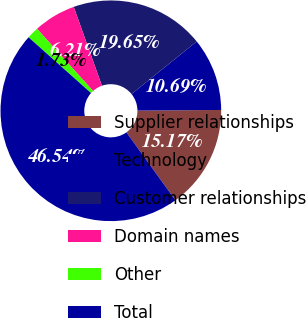<chart> <loc_0><loc_0><loc_500><loc_500><pie_chart><fcel>Supplier relationships<fcel>Technology<fcel>Customer relationships<fcel>Domain names<fcel>Other<fcel>Total<nl><fcel>15.17%<fcel>10.69%<fcel>19.65%<fcel>6.21%<fcel>1.73%<fcel>46.54%<nl></chart> 